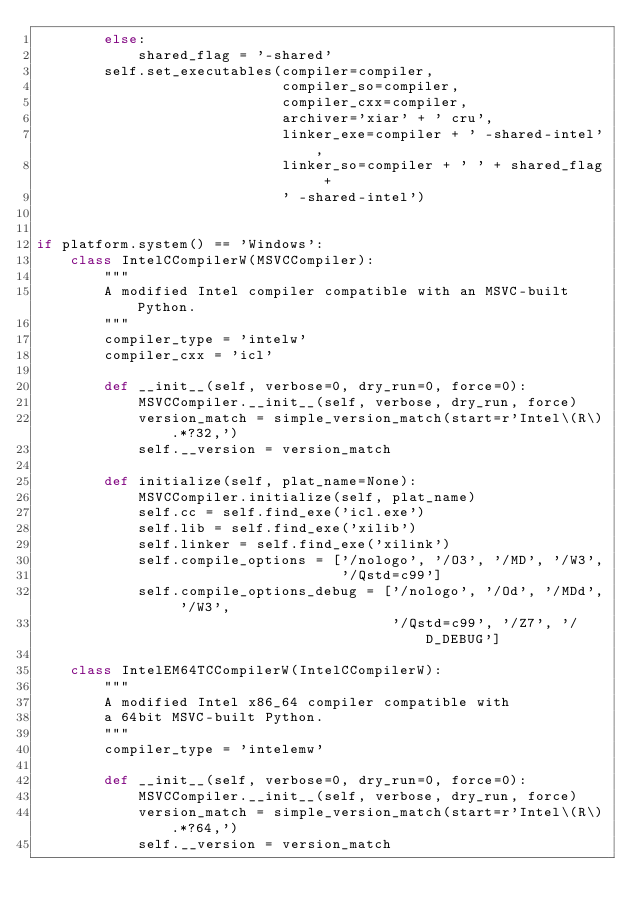<code> <loc_0><loc_0><loc_500><loc_500><_Python_>        else:
            shared_flag = '-shared'
        self.set_executables(compiler=compiler,
                             compiler_so=compiler,
                             compiler_cxx=compiler,
                             archiver='xiar' + ' cru',
                             linker_exe=compiler + ' -shared-intel',
                             linker_so=compiler + ' ' + shared_flag +
                             ' -shared-intel')


if platform.system() == 'Windows':
    class IntelCCompilerW(MSVCCompiler):
        """
        A modified Intel compiler compatible with an MSVC-built Python.
        """
        compiler_type = 'intelw'
        compiler_cxx = 'icl'

        def __init__(self, verbose=0, dry_run=0, force=0):
            MSVCCompiler.__init__(self, verbose, dry_run, force)
            version_match = simple_version_match(start=r'Intel\(R\).*?32,')
            self.__version = version_match

        def initialize(self, plat_name=None):
            MSVCCompiler.initialize(self, plat_name)
            self.cc = self.find_exe('icl.exe')
            self.lib = self.find_exe('xilib')
            self.linker = self.find_exe('xilink')
            self.compile_options = ['/nologo', '/O3', '/MD', '/W3',
                                    '/Qstd=c99']
            self.compile_options_debug = ['/nologo', '/Od', '/MDd', '/W3',
                                          '/Qstd=c99', '/Z7', '/D_DEBUG']

    class IntelEM64TCCompilerW(IntelCCompilerW):
        """
        A modified Intel x86_64 compiler compatible with
        a 64bit MSVC-built Python.
        """
        compiler_type = 'intelemw'

        def __init__(self, verbose=0, dry_run=0, force=0):
            MSVCCompiler.__init__(self, verbose, dry_run, force)
            version_match = simple_version_match(start=r'Intel\(R\).*?64,')
            self.__version = version_match
</code> 